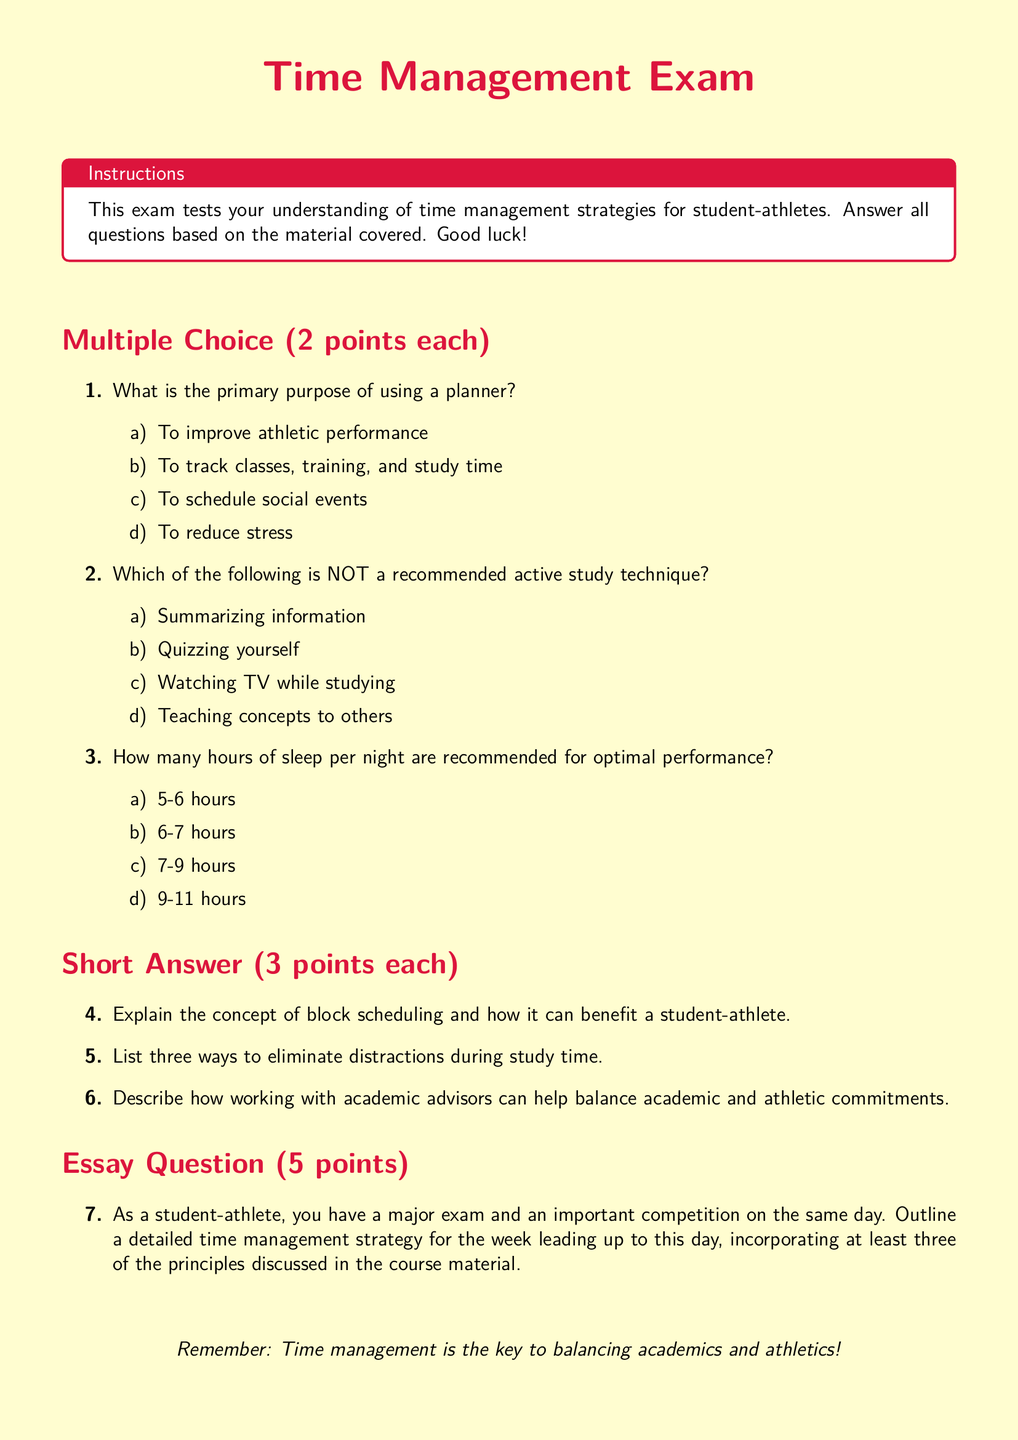What is the main color used for the title? The title is styled with a specific color defined as runnerred, which is RGB(220, 20, 60).
Answer: runnerred How many points is each multiple-choice question worth? The multiple-choice questions in the exam are specified to be worth 2 points each.
Answer: 2 points What is the recommended amount of sleep for optimal performance? The document states that 7-9 hours of sleep per night is recommended for optimal performance.
Answer: 7-9 hours What type of question is outlined at the end of the exam? The final question type specified in the exam structure is an essay question.
Answer: Essay Question List one active study technique that is NOT recommended. The document indicates that watching TV while studying is NOT a recommended active study technique.
Answer: Watching TV while studying What is the total number of short-answer questions in the exam? There are three short-answer questions listed after the multiple-choice section in the exam.
Answer: 3 How many principles should be incorporated in the essay question's time management strategy? The essay question specifies that at least three principles discussed in the course material should be incorporated.
Answer: Three principles 